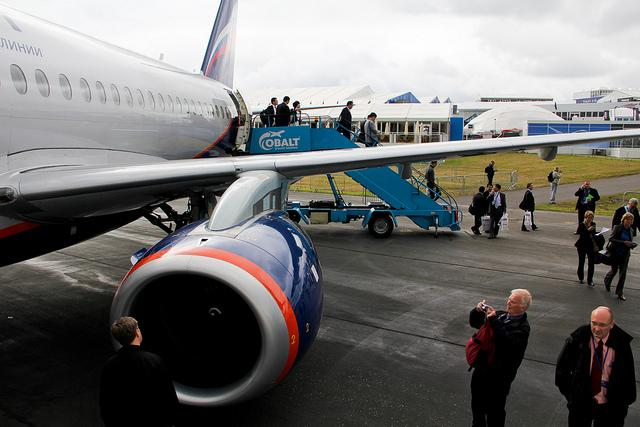What is the man with the red backpack on the right doing?

Choices:
A) drawing
B) exercising
C) taking photo
D) playing instrument taking photo 